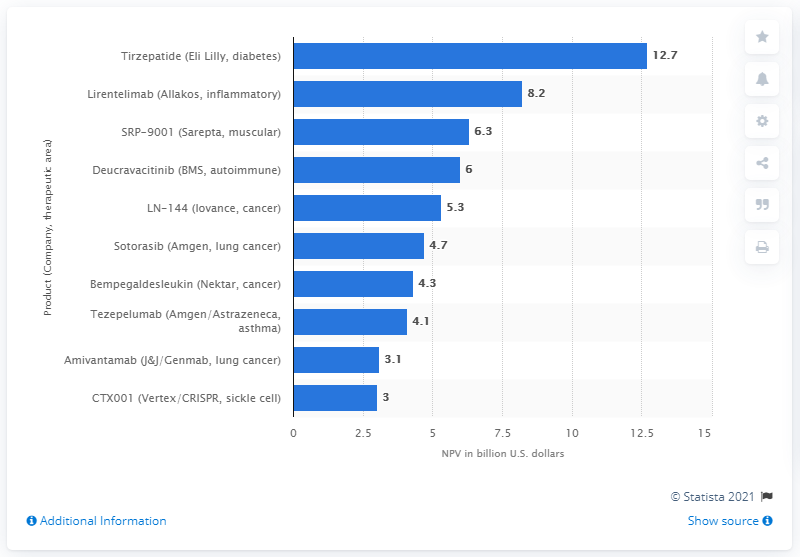Identify some key points in this picture. The net present value of Tirzepatide was 12.7.. 